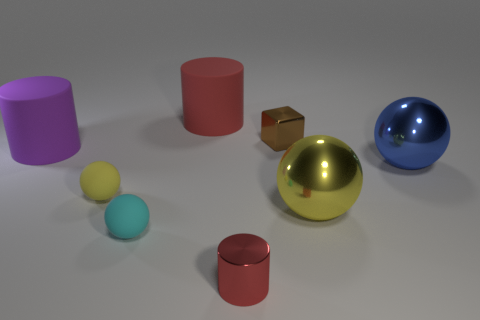Subtract all cyan spheres. How many spheres are left? 3 Subtract all red balls. Subtract all red blocks. How many balls are left? 4 Add 2 big purple matte spheres. How many objects exist? 10 Subtract all cylinders. How many objects are left? 5 Subtract 0 gray spheres. How many objects are left? 8 Subtract all big green metallic blocks. Subtract all red shiny cylinders. How many objects are left? 7 Add 4 small metal cylinders. How many small metal cylinders are left? 5 Add 6 yellow matte objects. How many yellow matte objects exist? 7 